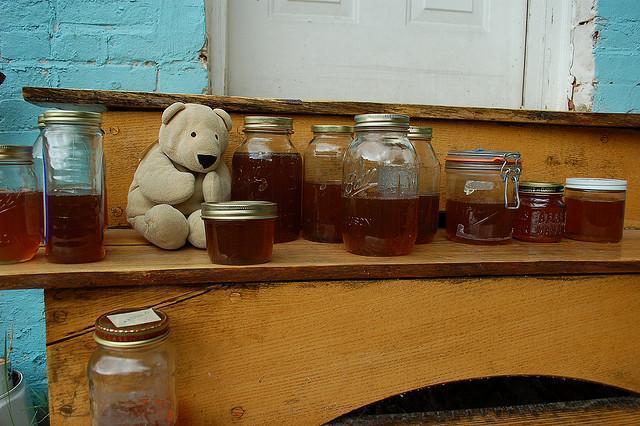How many jars are there?
Give a very brief answer. 11. How many bottles can be seen?
Give a very brief answer. 8. 